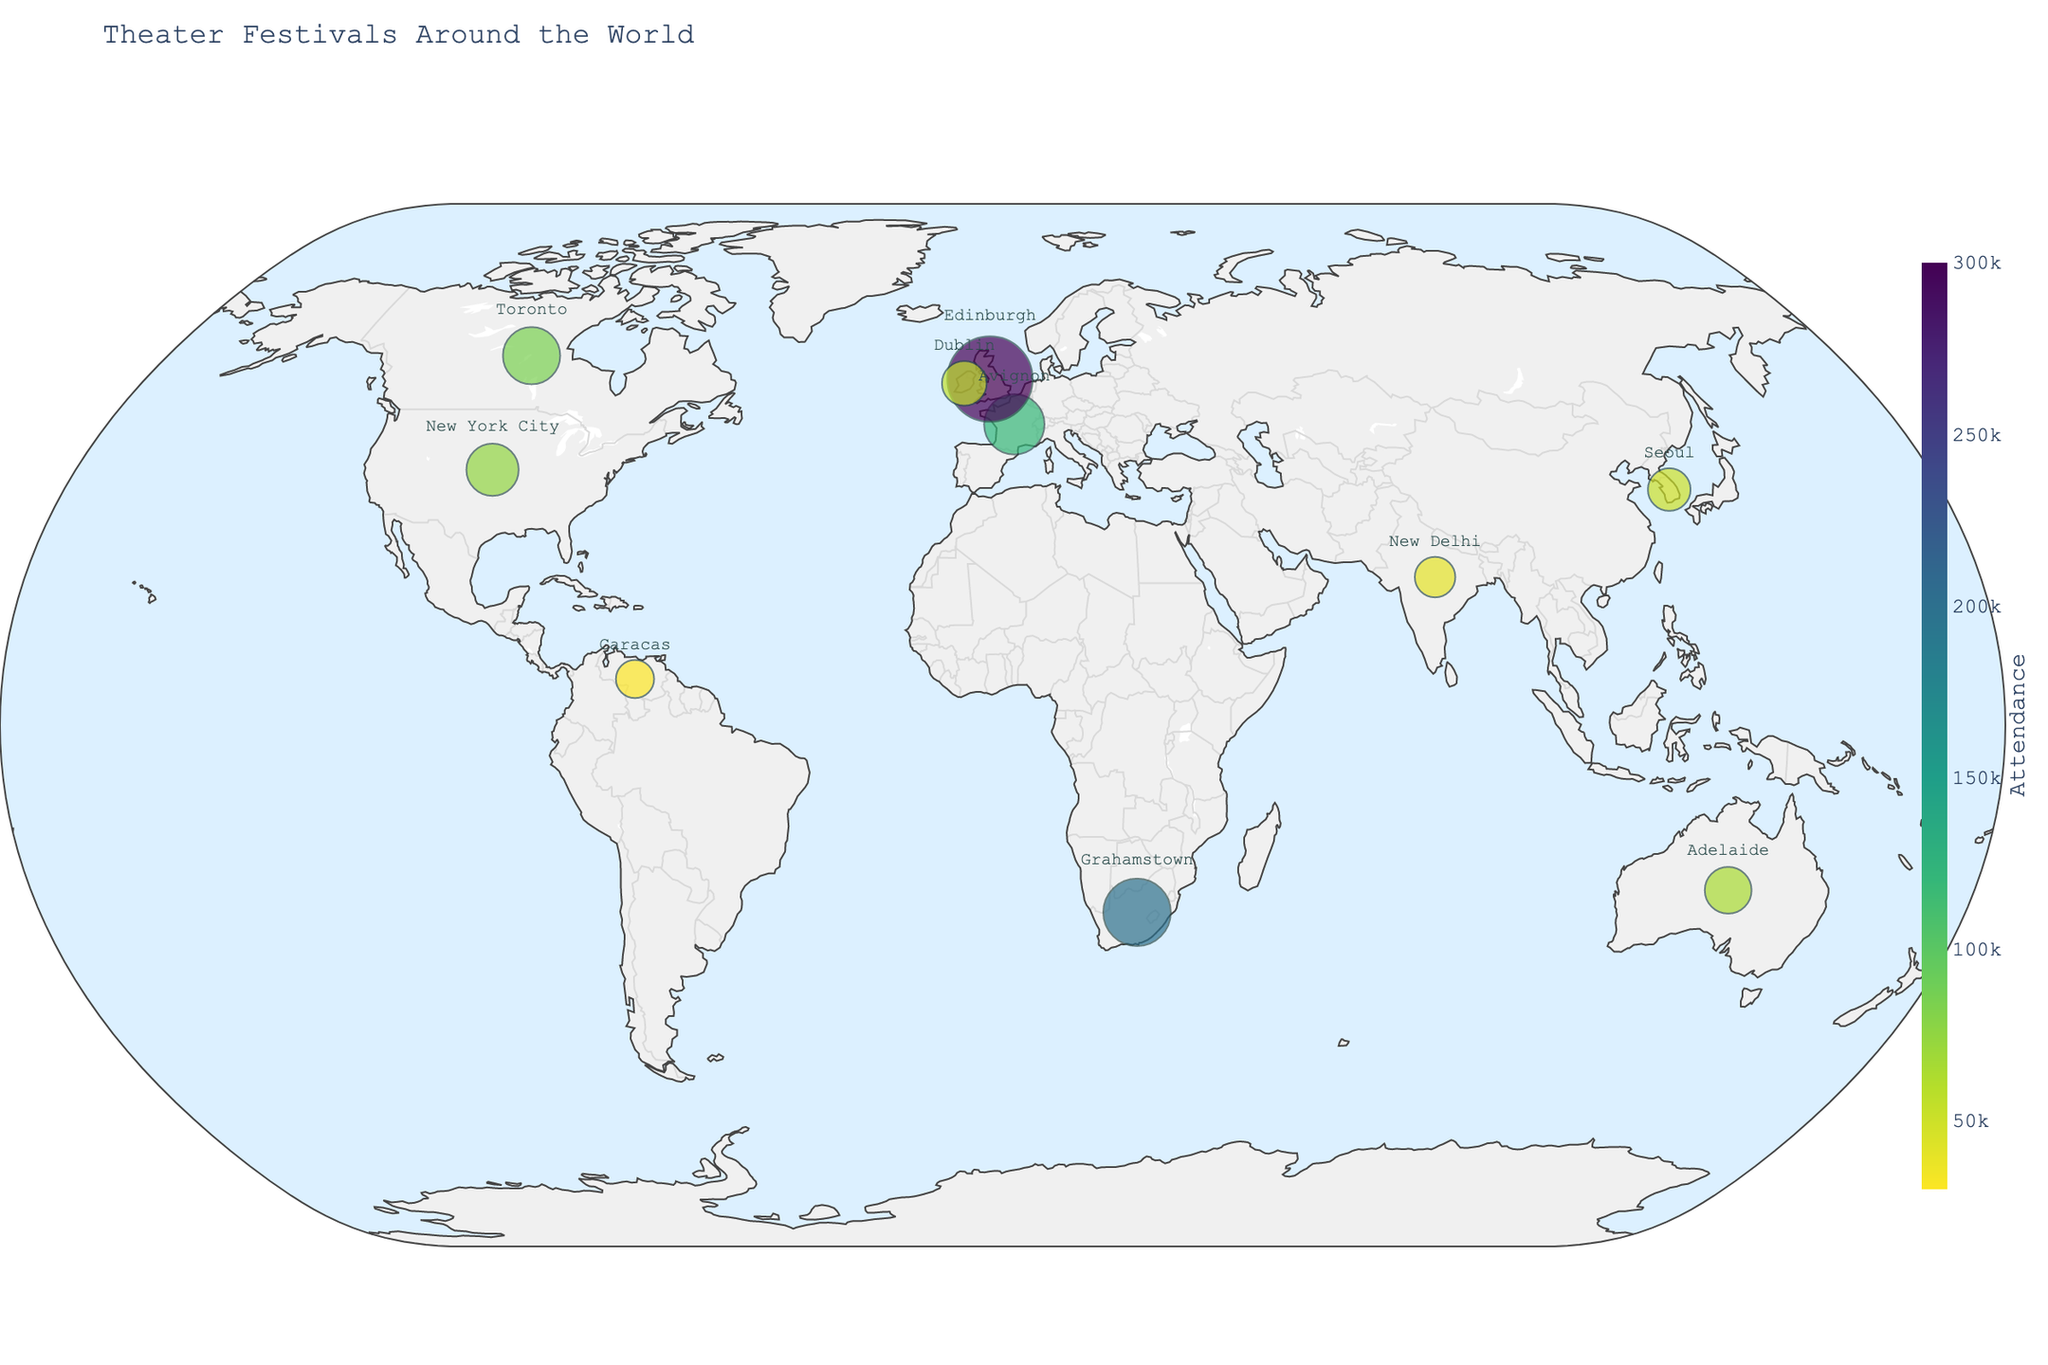What is the title of the figure? The title is located at the top of the map and gives an overview of what the figure represents. Reading the title directly answers this question.
Answer: Theater Festivals Around the World How many theater festivals are represented in the figure? Count the number of distinct data points or markers on the map to determine the number of theater festivals.
Answer: 10 Which continent has the highest-attended theater festival? Identify the festival with the highest attendance by looking at the color bar and locating the darkest marker, then figure out which continent it's on.
Answer: Europe What is the total attendance for the European festivals? Sum the attendance figures for all the European theater festivals listed.
Answer: 475,000 Which festival uses the most props? Look for the festival with the largest marker (since size represents the number of props used).
Answer: Edinburgh Festival Fringe Compare the attendance between the Edinburgh Festival Fringe and the National Arts Festival. Which one has more attendees and by how much? Find the attendance figures for both festivals and subtract the smaller from the larger.
Answer: Edinburgh Festival Fringe by 100,000 Are there more festivals in North America or Europe? Count the number of festivals located in each continent.
Answer: Europe Which festival in Asia has the lowest attendance? Look at the data points in Asia and compare their attendance figures to identify the lowest.
Answer: Bharat Rang Mahotsav What is the average number of props used across all festivals? Sum the number of props used for all festivals and divide by the total number of festivals (10).
Answer: 168 props Which continent has the fewest number of theater festivals represented in the figure? Count the number of festivals on each continent and identify the smallest count.
Answer: South America 